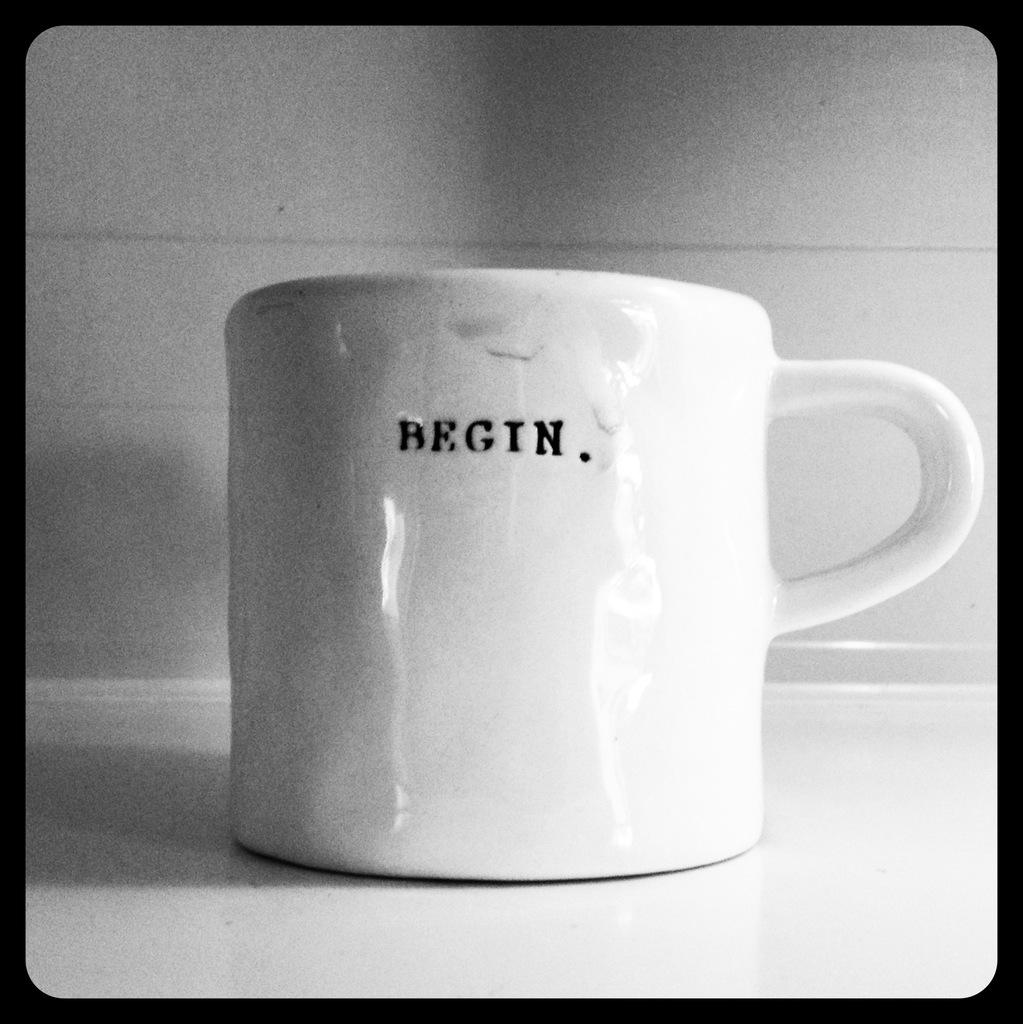What does it say on the mug?
Provide a succinct answer. Begin. 